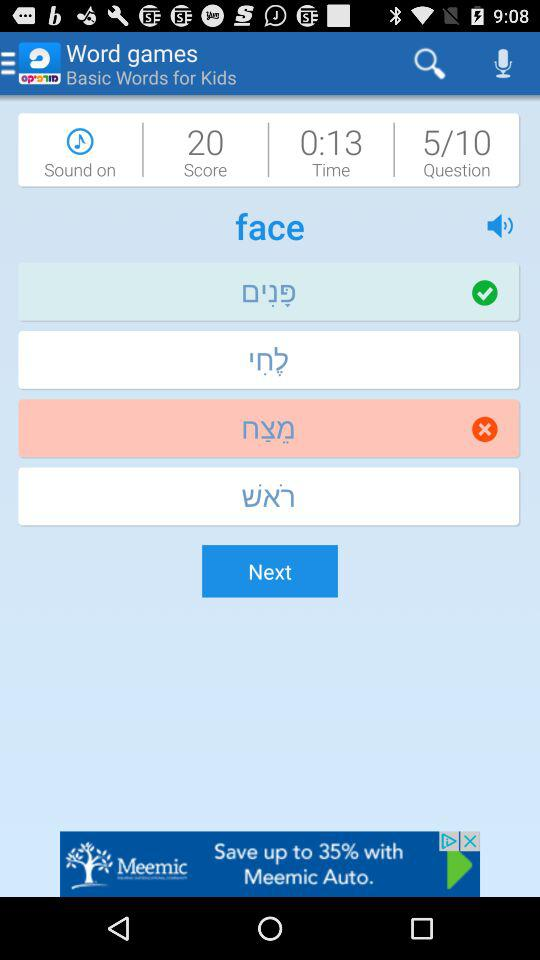Which question number are we currently on? You are currently on question number 5. 